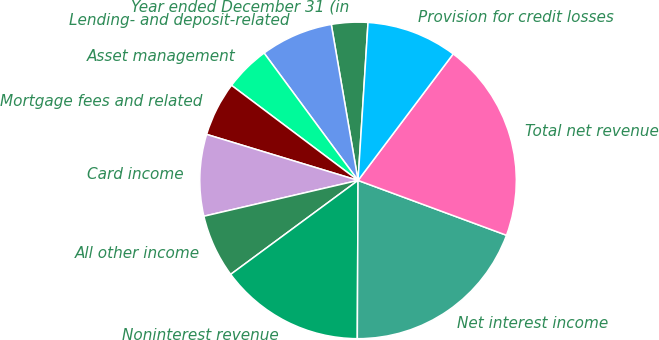Convert chart to OTSL. <chart><loc_0><loc_0><loc_500><loc_500><pie_chart><fcel>Year ended December 31 (in<fcel>Lending- and deposit-related<fcel>Asset management<fcel>Mortgage fees and related<fcel>Card income<fcel>All other income<fcel>Noninterest revenue<fcel>Net interest income<fcel>Total net revenue<fcel>Provision for credit losses<nl><fcel>3.71%<fcel>7.41%<fcel>4.63%<fcel>5.56%<fcel>8.33%<fcel>6.48%<fcel>14.81%<fcel>19.44%<fcel>20.37%<fcel>9.26%<nl></chart> 